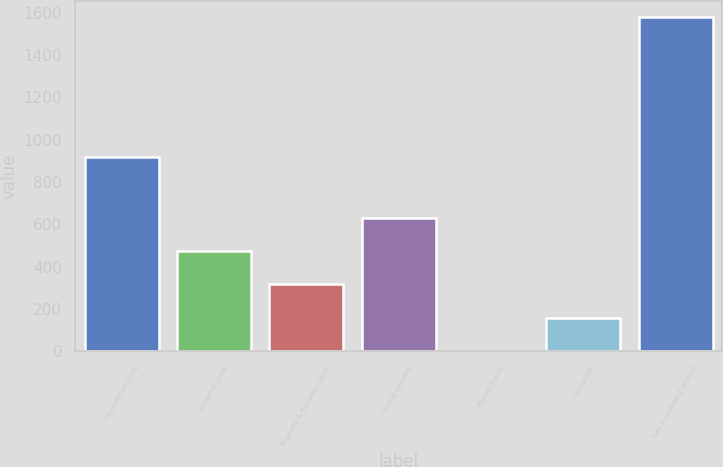Convert chart to OTSL. <chart><loc_0><loc_0><loc_500><loc_500><bar_chart><fcel>Commercial Lines<fcel>Personal Lines<fcel>Property & Casualty Other<fcel>Group Benefits<fcel>Mutual Funds<fcel>Corporate<fcel>Net investment income<nl><fcel>917<fcel>473.8<fcel>316.2<fcel>631.4<fcel>1<fcel>158.6<fcel>1577<nl></chart> 